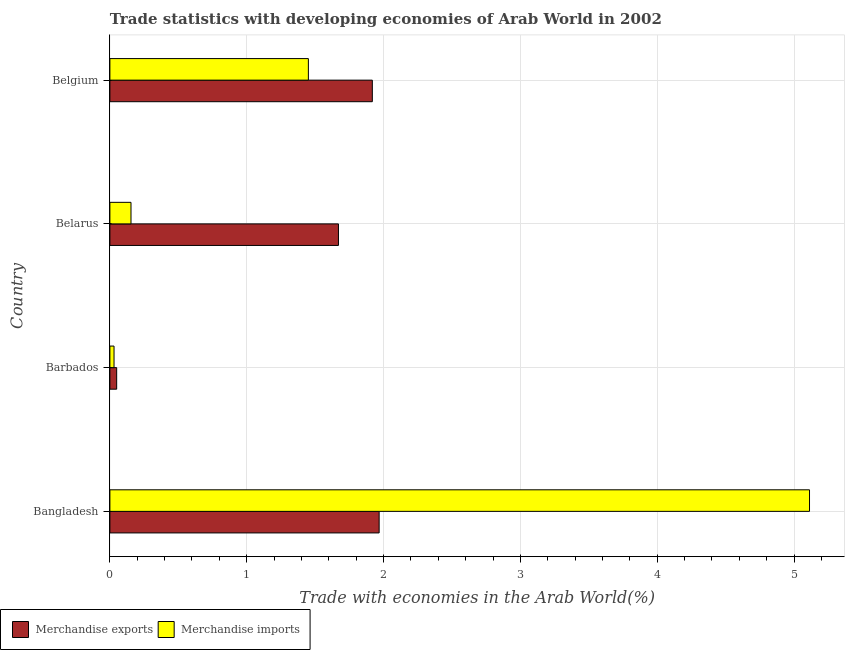How many different coloured bars are there?
Ensure brevity in your answer.  2. Are the number of bars per tick equal to the number of legend labels?
Offer a terse response. Yes. How many bars are there on the 4th tick from the bottom?
Offer a terse response. 2. What is the label of the 2nd group of bars from the top?
Provide a succinct answer. Belarus. In how many cases, is the number of bars for a given country not equal to the number of legend labels?
Make the answer very short. 0. What is the merchandise exports in Barbados?
Your answer should be compact. 0.05. Across all countries, what is the maximum merchandise exports?
Provide a short and direct response. 1.97. Across all countries, what is the minimum merchandise imports?
Your answer should be very brief. 0.03. In which country was the merchandise imports maximum?
Offer a terse response. Bangladesh. In which country was the merchandise exports minimum?
Offer a terse response. Barbados. What is the total merchandise imports in the graph?
Your response must be concise. 6.75. What is the difference between the merchandise imports in Barbados and that in Belarus?
Ensure brevity in your answer.  -0.12. What is the difference between the merchandise imports in Bangladesh and the merchandise exports in Belarus?
Provide a succinct answer. 3.44. What is the average merchandise exports per country?
Your response must be concise. 1.4. What is the difference between the merchandise imports and merchandise exports in Barbados?
Offer a terse response. -0.02. What is the ratio of the merchandise imports in Barbados to that in Belgium?
Give a very brief answer. 0.02. Is the merchandise imports in Bangladesh less than that in Belgium?
Your answer should be compact. No. Is the difference between the merchandise imports in Belarus and Belgium greater than the difference between the merchandise exports in Belarus and Belgium?
Ensure brevity in your answer.  No. What is the difference between the highest and the second highest merchandise imports?
Your answer should be very brief. 3.66. What is the difference between the highest and the lowest merchandise imports?
Keep it short and to the point. 5.08. Is the sum of the merchandise exports in Bangladesh and Belarus greater than the maximum merchandise imports across all countries?
Your answer should be compact. No. What does the 2nd bar from the top in Belarus represents?
Keep it short and to the point. Merchandise exports. Are all the bars in the graph horizontal?
Make the answer very short. Yes. How many countries are there in the graph?
Keep it short and to the point. 4. What is the difference between two consecutive major ticks on the X-axis?
Your answer should be very brief. 1. Are the values on the major ticks of X-axis written in scientific E-notation?
Your answer should be very brief. No. Does the graph contain any zero values?
Offer a very short reply. No. How are the legend labels stacked?
Ensure brevity in your answer.  Horizontal. What is the title of the graph?
Provide a succinct answer. Trade statistics with developing economies of Arab World in 2002. What is the label or title of the X-axis?
Provide a short and direct response. Trade with economies in the Arab World(%). What is the Trade with economies in the Arab World(%) in Merchandise exports in Bangladesh?
Your response must be concise. 1.97. What is the Trade with economies in the Arab World(%) of Merchandise imports in Bangladesh?
Make the answer very short. 5.11. What is the Trade with economies in the Arab World(%) in Merchandise exports in Barbados?
Offer a very short reply. 0.05. What is the Trade with economies in the Arab World(%) in Merchandise imports in Barbados?
Offer a terse response. 0.03. What is the Trade with economies in the Arab World(%) of Merchandise exports in Belarus?
Make the answer very short. 1.67. What is the Trade with economies in the Arab World(%) of Merchandise imports in Belarus?
Offer a very short reply. 0.15. What is the Trade with economies in the Arab World(%) in Merchandise exports in Belgium?
Provide a short and direct response. 1.92. What is the Trade with economies in the Arab World(%) of Merchandise imports in Belgium?
Your answer should be very brief. 1.45. Across all countries, what is the maximum Trade with economies in the Arab World(%) of Merchandise exports?
Your answer should be compact. 1.97. Across all countries, what is the maximum Trade with economies in the Arab World(%) of Merchandise imports?
Offer a very short reply. 5.11. Across all countries, what is the minimum Trade with economies in the Arab World(%) of Merchandise exports?
Provide a short and direct response. 0.05. Across all countries, what is the minimum Trade with economies in the Arab World(%) of Merchandise imports?
Your response must be concise. 0.03. What is the total Trade with economies in the Arab World(%) of Merchandise exports in the graph?
Your answer should be compact. 5.61. What is the total Trade with economies in the Arab World(%) in Merchandise imports in the graph?
Your answer should be very brief. 6.75. What is the difference between the Trade with economies in the Arab World(%) of Merchandise exports in Bangladesh and that in Barbados?
Keep it short and to the point. 1.92. What is the difference between the Trade with economies in the Arab World(%) in Merchandise imports in Bangladesh and that in Barbados?
Ensure brevity in your answer.  5.08. What is the difference between the Trade with economies in the Arab World(%) in Merchandise exports in Bangladesh and that in Belarus?
Your answer should be very brief. 0.3. What is the difference between the Trade with economies in the Arab World(%) of Merchandise imports in Bangladesh and that in Belarus?
Your answer should be compact. 4.96. What is the difference between the Trade with economies in the Arab World(%) in Merchandise exports in Bangladesh and that in Belgium?
Give a very brief answer. 0.05. What is the difference between the Trade with economies in the Arab World(%) of Merchandise imports in Bangladesh and that in Belgium?
Give a very brief answer. 3.66. What is the difference between the Trade with economies in the Arab World(%) of Merchandise exports in Barbados and that in Belarus?
Your answer should be very brief. -1.62. What is the difference between the Trade with economies in the Arab World(%) of Merchandise imports in Barbados and that in Belarus?
Offer a terse response. -0.12. What is the difference between the Trade with economies in the Arab World(%) in Merchandise exports in Barbados and that in Belgium?
Provide a succinct answer. -1.87. What is the difference between the Trade with economies in the Arab World(%) of Merchandise imports in Barbados and that in Belgium?
Your answer should be compact. -1.42. What is the difference between the Trade with economies in the Arab World(%) in Merchandise exports in Belarus and that in Belgium?
Your response must be concise. -0.25. What is the difference between the Trade with economies in the Arab World(%) in Merchandise imports in Belarus and that in Belgium?
Make the answer very short. -1.3. What is the difference between the Trade with economies in the Arab World(%) of Merchandise exports in Bangladesh and the Trade with economies in the Arab World(%) of Merchandise imports in Barbados?
Provide a short and direct response. 1.94. What is the difference between the Trade with economies in the Arab World(%) of Merchandise exports in Bangladesh and the Trade with economies in the Arab World(%) of Merchandise imports in Belarus?
Your answer should be very brief. 1.81. What is the difference between the Trade with economies in the Arab World(%) in Merchandise exports in Bangladesh and the Trade with economies in the Arab World(%) in Merchandise imports in Belgium?
Provide a succinct answer. 0.52. What is the difference between the Trade with economies in the Arab World(%) of Merchandise exports in Barbados and the Trade with economies in the Arab World(%) of Merchandise imports in Belarus?
Provide a short and direct response. -0.1. What is the difference between the Trade with economies in the Arab World(%) in Merchandise exports in Barbados and the Trade with economies in the Arab World(%) in Merchandise imports in Belgium?
Offer a very short reply. -1.4. What is the difference between the Trade with economies in the Arab World(%) in Merchandise exports in Belarus and the Trade with economies in the Arab World(%) in Merchandise imports in Belgium?
Your answer should be compact. 0.22. What is the average Trade with economies in the Arab World(%) of Merchandise exports per country?
Ensure brevity in your answer.  1.4. What is the average Trade with economies in the Arab World(%) in Merchandise imports per country?
Offer a very short reply. 1.69. What is the difference between the Trade with economies in the Arab World(%) in Merchandise exports and Trade with economies in the Arab World(%) in Merchandise imports in Bangladesh?
Offer a very short reply. -3.15. What is the difference between the Trade with economies in the Arab World(%) of Merchandise exports and Trade with economies in the Arab World(%) of Merchandise imports in Barbados?
Your response must be concise. 0.02. What is the difference between the Trade with economies in the Arab World(%) of Merchandise exports and Trade with economies in the Arab World(%) of Merchandise imports in Belarus?
Give a very brief answer. 1.52. What is the difference between the Trade with economies in the Arab World(%) in Merchandise exports and Trade with economies in the Arab World(%) in Merchandise imports in Belgium?
Provide a short and direct response. 0.47. What is the ratio of the Trade with economies in the Arab World(%) of Merchandise exports in Bangladesh to that in Barbados?
Offer a terse response. 39.73. What is the ratio of the Trade with economies in the Arab World(%) in Merchandise imports in Bangladesh to that in Barbados?
Your response must be concise. 168.8. What is the ratio of the Trade with economies in the Arab World(%) of Merchandise exports in Bangladesh to that in Belarus?
Offer a very short reply. 1.18. What is the ratio of the Trade with economies in the Arab World(%) in Merchandise imports in Bangladesh to that in Belarus?
Your response must be concise. 33.15. What is the ratio of the Trade with economies in the Arab World(%) of Merchandise exports in Bangladesh to that in Belgium?
Ensure brevity in your answer.  1.03. What is the ratio of the Trade with economies in the Arab World(%) of Merchandise imports in Bangladesh to that in Belgium?
Your response must be concise. 3.52. What is the ratio of the Trade with economies in the Arab World(%) of Merchandise exports in Barbados to that in Belarus?
Give a very brief answer. 0.03. What is the ratio of the Trade with economies in the Arab World(%) of Merchandise imports in Barbados to that in Belarus?
Offer a very short reply. 0.2. What is the ratio of the Trade with economies in the Arab World(%) in Merchandise exports in Barbados to that in Belgium?
Provide a succinct answer. 0.03. What is the ratio of the Trade with economies in the Arab World(%) of Merchandise imports in Barbados to that in Belgium?
Offer a very short reply. 0.02. What is the ratio of the Trade with economies in the Arab World(%) in Merchandise exports in Belarus to that in Belgium?
Provide a succinct answer. 0.87. What is the ratio of the Trade with economies in the Arab World(%) of Merchandise imports in Belarus to that in Belgium?
Keep it short and to the point. 0.11. What is the difference between the highest and the second highest Trade with economies in the Arab World(%) of Merchandise exports?
Offer a terse response. 0.05. What is the difference between the highest and the second highest Trade with economies in the Arab World(%) of Merchandise imports?
Your answer should be very brief. 3.66. What is the difference between the highest and the lowest Trade with economies in the Arab World(%) of Merchandise exports?
Keep it short and to the point. 1.92. What is the difference between the highest and the lowest Trade with economies in the Arab World(%) in Merchandise imports?
Your response must be concise. 5.08. 